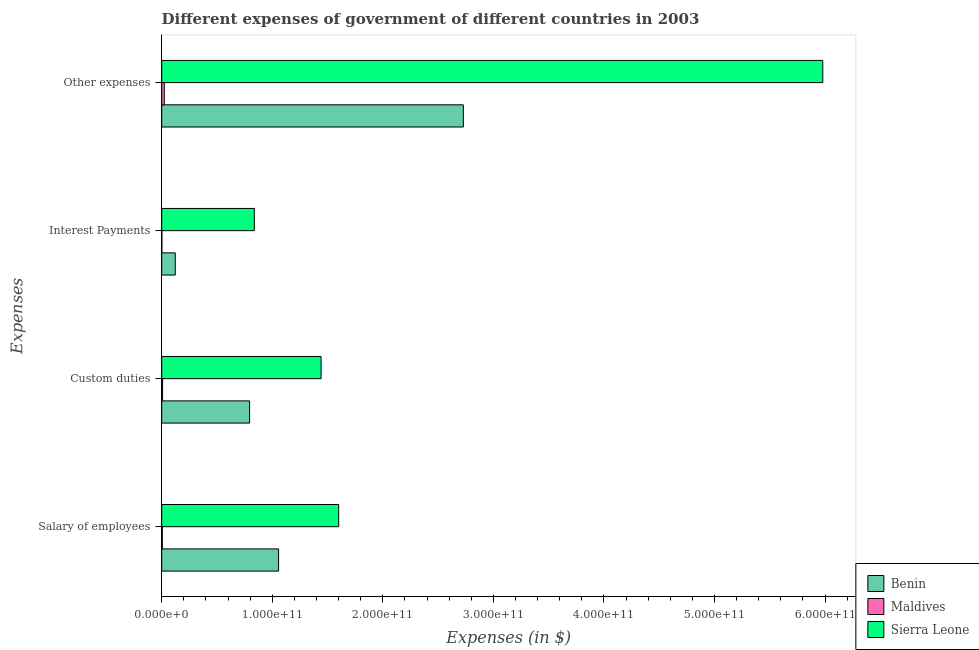How many different coloured bars are there?
Your response must be concise. 3. How many groups of bars are there?
Offer a terse response. 4. Are the number of bars per tick equal to the number of legend labels?
Offer a terse response. Yes. Are the number of bars on each tick of the Y-axis equal?
Your answer should be compact. Yes. How many bars are there on the 4th tick from the top?
Your answer should be compact. 3. What is the label of the 2nd group of bars from the top?
Ensure brevity in your answer.  Interest Payments. What is the amount spent on interest payments in Maldives?
Your answer should be compact. 1.35e+08. Across all countries, what is the maximum amount spent on other expenses?
Keep it short and to the point. 5.98e+11. Across all countries, what is the minimum amount spent on interest payments?
Ensure brevity in your answer.  1.35e+08. In which country was the amount spent on custom duties maximum?
Give a very brief answer. Sierra Leone. In which country was the amount spent on interest payments minimum?
Make the answer very short. Maldives. What is the total amount spent on other expenses in the graph?
Offer a very short reply. 8.73e+11. What is the difference between the amount spent on salary of employees in Maldives and that in Sierra Leone?
Offer a terse response. -1.60e+11. What is the difference between the amount spent on other expenses in Sierra Leone and the amount spent on salary of employees in Maldives?
Give a very brief answer. 5.97e+11. What is the average amount spent on interest payments per country?
Make the answer very short. 3.21e+1. What is the difference between the amount spent on interest payments and amount spent on custom duties in Benin?
Make the answer very short. -6.72e+1. In how many countries, is the amount spent on salary of employees greater than 500000000000 $?
Your answer should be very brief. 0. What is the ratio of the amount spent on salary of employees in Sierra Leone to that in Benin?
Your answer should be very brief. 1.51. Is the amount spent on custom duties in Sierra Leone less than that in Benin?
Make the answer very short. No. Is the difference between the amount spent on custom duties in Sierra Leone and Maldives greater than the difference between the amount spent on interest payments in Sierra Leone and Maldives?
Offer a very short reply. Yes. What is the difference between the highest and the second highest amount spent on interest payments?
Make the answer very short. 7.15e+1. What is the difference between the highest and the lowest amount spent on custom duties?
Offer a terse response. 1.43e+11. In how many countries, is the amount spent on interest payments greater than the average amount spent on interest payments taken over all countries?
Your response must be concise. 1. Is the sum of the amount spent on custom duties in Sierra Leone and Maldives greater than the maximum amount spent on other expenses across all countries?
Your answer should be compact. No. Is it the case that in every country, the sum of the amount spent on custom duties and amount spent on other expenses is greater than the sum of amount spent on interest payments and amount spent on salary of employees?
Your response must be concise. No. What does the 3rd bar from the top in Interest Payments represents?
Provide a short and direct response. Benin. What does the 2nd bar from the bottom in Interest Payments represents?
Offer a very short reply. Maldives. Is it the case that in every country, the sum of the amount spent on salary of employees and amount spent on custom duties is greater than the amount spent on interest payments?
Your answer should be very brief. Yes. How many bars are there?
Make the answer very short. 12. What is the difference between two consecutive major ticks on the X-axis?
Keep it short and to the point. 1.00e+11. Are the values on the major ticks of X-axis written in scientific E-notation?
Make the answer very short. Yes. Does the graph contain any zero values?
Your response must be concise. No. How many legend labels are there?
Your answer should be compact. 3. How are the legend labels stacked?
Offer a terse response. Vertical. What is the title of the graph?
Give a very brief answer. Different expenses of government of different countries in 2003. What is the label or title of the X-axis?
Your answer should be compact. Expenses (in $). What is the label or title of the Y-axis?
Your answer should be very brief. Expenses. What is the Expenses (in $) of Benin in Salary of employees?
Provide a short and direct response. 1.06e+11. What is the Expenses (in $) of Maldives in Salary of employees?
Your response must be concise. 5.64e+08. What is the Expenses (in $) in Sierra Leone in Salary of employees?
Offer a terse response. 1.60e+11. What is the Expenses (in $) of Benin in Custom duties?
Make the answer very short. 7.95e+1. What is the Expenses (in $) of Maldives in Custom duties?
Your answer should be very brief. 8.17e+08. What is the Expenses (in $) in Sierra Leone in Custom duties?
Your answer should be very brief. 1.44e+11. What is the Expenses (in $) of Benin in Interest Payments?
Offer a terse response. 1.23e+1. What is the Expenses (in $) in Maldives in Interest Payments?
Ensure brevity in your answer.  1.35e+08. What is the Expenses (in $) of Sierra Leone in Interest Payments?
Provide a succinct answer. 8.38e+1. What is the Expenses (in $) of Benin in Other expenses?
Offer a very short reply. 2.73e+11. What is the Expenses (in $) in Maldives in Other expenses?
Provide a succinct answer. 2.35e+09. What is the Expenses (in $) of Sierra Leone in Other expenses?
Offer a terse response. 5.98e+11. Across all Expenses, what is the maximum Expenses (in $) in Benin?
Provide a succinct answer. 2.73e+11. Across all Expenses, what is the maximum Expenses (in $) in Maldives?
Your response must be concise. 2.35e+09. Across all Expenses, what is the maximum Expenses (in $) of Sierra Leone?
Your answer should be very brief. 5.98e+11. Across all Expenses, what is the minimum Expenses (in $) of Benin?
Keep it short and to the point. 1.23e+1. Across all Expenses, what is the minimum Expenses (in $) of Maldives?
Your answer should be compact. 1.35e+08. Across all Expenses, what is the minimum Expenses (in $) of Sierra Leone?
Give a very brief answer. 8.38e+1. What is the total Expenses (in $) in Benin in the graph?
Your answer should be very brief. 4.70e+11. What is the total Expenses (in $) in Maldives in the graph?
Keep it short and to the point. 3.86e+09. What is the total Expenses (in $) of Sierra Leone in the graph?
Keep it short and to the point. 9.86e+11. What is the difference between the Expenses (in $) of Benin in Salary of employees and that in Custom duties?
Your answer should be compact. 2.62e+1. What is the difference between the Expenses (in $) of Maldives in Salary of employees and that in Custom duties?
Keep it short and to the point. -2.53e+08. What is the difference between the Expenses (in $) in Sierra Leone in Salary of employees and that in Custom duties?
Your answer should be very brief. 1.59e+1. What is the difference between the Expenses (in $) of Benin in Salary of employees and that in Interest Payments?
Your answer should be compact. 9.35e+1. What is the difference between the Expenses (in $) of Maldives in Salary of employees and that in Interest Payments?
Your answer should be very brief. 4.29e+08. What is the difference between the Expenses (in $) in Sierra Leone in Salary of employees and that in Interest Payments?
Offer a terse response. 7.63e+1. What is the difference between the Expenses (in $) in Benin in Salary of employees and that in Other expenses?
Your answer should be compact. -1.67e+11. What is the difference between the Expenses (in $) in Maldives in Salary of employees and that in Other expenses?
Your answer should be compact. -1.78e+09. What is the difference between the Expenses (in $) in Sierra Leone in Salary of employees and that in Other expenses?
Make the answer very short. -4.38e+11. What is the difference between the Expenses (in $) in Benin in Custom duties and that in Interest Payments?
Give a very brief answer. 6.72e+1. What is the difference between the Expenses (in $) of Maldives in Custom duties and that in Interest Payments?
Offer a very short reply. 6.82e+08. What is the difference between the Expenses (in $) of Sierra Leone in Custom duties and that in Interest Payments?
Provide a succinct answer. 6.04e+1. What is the difference between the Expenses (in $) of Benin in Custom duties and that in Other expenses?
Provide a succinct answer. -1.93e+11. What is the difference between the Expenses (in $) of Maldives in Custom duties and that in Other expenses?
Keep it short and to the point. -1.53e+09. What is the difference between the Expenses (in $) of Sierra Leone in Custom duties and that in Other expenses?
Make the answer very short. -4.54e+11. What is the difference between the Expenses (in $) of Benin in Interest Payments and that in Other expenses?
Your answer should be compact. -2.61e+11. What is the difference between the Expenses (in $) in Maldives in Interest Payments and that in Other expenses?
Offer a very short reply. -2.21e+09. What is the difference between the Expenses (in $) in Sierra Leone in Interest Payments and that in Other expenses?
Provide a succinct answer. -5.14e+11. What is the difference between the Expenses (in $) in Benin in Salary of employees and the Expenses (in $) in Maldives in Custom duties?
Give a very brief answer. 1.05e+11. What is the difference between the Expenses (in $) of Benin in Salary of employees and the Expenses (in $) of Sierra Leone in Custom duties?
Make the answer very short. -3.84e+1. What is the difference between the Expenses (in $) in Maldives in Salary of employees and the Expenses (in $) in Sierra Leone in Custom duties?
Provide a short and direct response. -1.44e+11. What is the difference between the Expenses (in $) in Benin in Salary of employees and the Expenses (in $) in Maldives in Interest Payments?
Your response must be concise. 1.06e+11. What is the difference between the Expenses (in $) in Benin in Salary of employees and the Expenses (in $) in Sierra Leone in Interest Payments?
Your response must be concise. 2.19e+1. What is the difference between the Expenses (in $) of Maldives in Salary of employees and the Expenses (in $) of Sierra Leone in Interest Payments?
Give a very brief answer. -8.32e+1. What is the difference between the Expenses (in $) in Benin in Salary of employees and the Expenses (in $) in Maldives in Other expenses?
Give a very brief answer. 1.03e+11. What is the difference between the Expenses (in $) in Benin in Salary of employees and the Expenses (in $) in Sierra Leone in Other expenses?
Your response must be concise. -4.92e+11. What is the difference between the Expenses (in $) in Maldives in Salary of employees and the Expenses (in $) in Sierra Leone in Other expenses?
Provide a succinct answer. -5.97e+11. What is the difference between the Expenses (in $) of Benin in Custom duties and the Expenses (in $) of Maldives in Interest Payments?
Offer a very short reply. 7.94e+1. What is the difference between the Expenses (in $) of Benin in Custom duties and the Expenses (in $) of Sierra Leone in Interest Payments?
Provide a succinct answer. -4.28e+09. What is the difference between the Expenses (in $) in Maldives in Custom duties and the Expenses (in $) in Sierra Leone in Interest Payments?
Provide a succinct answer. -8.30e+1. What is the difference between the Expenses (in $) in Benin in Custom duties and the Expenses (in $) in Maldives in Other expenses?
Your response must be concise. 7.71e+1. What is the difference between the Expenses (in $) of Benin in Custom duties and the Expenses (in $) of Sierra Leone in Other expenses?
Offer a very short reply. -5.19e+11. What is the difference between the Expenses (in $) in Maldives in Custom duties and the Expenses (in $) in Sierra Leone in Other expenses?
Your answer should be compact. -5.97e+11. What is the difference between the Expenses (in $) in Benin in Interest Payments and the Expenses (in $) in Maldives in Other expenses?
Provide a succinct answer. 9.92e+09. What is the difference between the Expenses (in $) in Benin in Interest Payments and the Expenses (in $) in Sierra Leone in Other expenses?
Provide a succinct answer. -5.86e+11. What is the difference between the Expenses (in $) in Maldives in Interest Payments and the Expenses (in $) in Sierra Leone in Other expenses?
Your answer should be compact. -5.98e+11. What is the average Expenses (in $) of Benin per Expenses?
Keep it short and to the point. 1.18e+11. What is the average Expenses (in $) in Maldives per Expenses?
Provide a succinct answer. 9.66e+08. What is the average Expenses (in $) in Sierra Leone per Expenses?
Keep it short and to the point. 2.47e+11. What is the difference between the Expenses (in $) in Benin and Expenses (in $) in Maldives in Salary of employees?
Offer a terse response. 1.05e+11. What is the difference between the Expenses (in $) in Benin and Expenses (in $) in Sierra Leone in Salary of employees?
Make the answer very short. -5.44e+1. What is the difference between the Expenses (in $) of Maldives and Expenses (in $) of Sierra Leone in Salary of employees?
Provide a short and direct response. -1.60e+11. What is the difference between the Expenses (in $) in Benin and Expenses (in $) in Maldives in Custom duties?
Your response must be concise. 7.87e+1. What is the difference between the Expenses (in $) in Benin and Expenses (in $) in Sierra Leone in Custom duties?
Your answer should be very brief. -6.47e+1. What is the difference between the Expenses (in $) of Maldives and Expenses (in $) of Sierra Leone in Custom duties?
Your response must be concise. -1.43e+11. What is the difference between the Expenses (in $) in Benin and Expenses (in $) in Maldives in Interest Payments?
Make the answer very short. 1.21e+1. What is the difference between the Expenses (in $) in Benin and Expenses (in $) in Sierra Leone in Interest Payments?
Provide a short and direct response. -7.15e+1. What is the difference between the Expenses (in $) in Maldives and Expenses (in $) in Sierra Leone in Interest Payments?
Offer a very short reply. -8.36e+1. What is the difference between the Expenses (in $) in Benin and Expenses (in $) in Maldives in Other expenses?
Your answer should be compact. 2.71e+11. What is the difference between the Expenses (in $) in Benin and Expenses (in $) in Sierra Leone in Other expenses?
Make the answer very short. -3.25e+11. What is the difference between the Expenses (in $) in Maldives and Expenses (in $) in Sierra Leone in Other expenses?
Your answer should be compact. -5.96e+11. What is the ratio of the Expenses (in $) of Benin in Salary of employees to that in Custom duties?
Ensure brevity in your answer.  1.33. What is the ratio of the Expenses (in $) of Maldives in Salary of employees to that in Custom duties?
Offer a very short reply. 0.69. What is the ratio of the Expenses (in $) in Sierra Leone in Salary of employees to that in Custom duties?
Offer a very short reply. 1.11. What is the ratio of the Expenses (in $) in Benin in Salary of employees to that in Interest Payments?
Keep it short and to the point. 8.62. What is the ratio of the Expenses (in $) of Maldives in Salary of employees to that in Interest Payments?
Ensure brevity in your answer.  4.17. What is the ratio of the Expenses (in $) of Sierra Leone in Salary of employees to that in Interest Payments?
Provide a short and direct response. 1.91. What is the ratio of the Expenses (in $) in Benin in Salary of employees to that in Other expenses?
Ensure brevity in your answer.  0.39. What is the ratio of the Expenses (in $) of Maldives in Salary of employees to that in Other expenses?
Keep it short and to the point. 0.24. What is the ratio of the Expenses (in $) in Sierra Leone in Salary of employees to that in Other expenses?
Give a very brief answer. 0.27. What is the ratio of the Expenses (in $) in Benin in Custom duties to that in Interest Payments?
Your response must be concise. 6.48. What is the ratio of the Expenses (in $) of Maldives in Custom duties to that in Interest Payments?
Your response must be concise. 6.04. What is the ratio of the Expenses (in $) of Sierra Leone in Custom duties to that in Interest Payments?
Keep it short and to the point. 1.72. What is the ratio of the Expenses (in $) in Benin in Custom duties to that in Other expenses?
Ensure brevity in your answer.  0.29. What is the ratio of the Expenses (in $) of Maldives in Custom duties to that in Other expenses?
Your answer should be very brief. 0.35. What is the ratio of the Expenses (in $) of Sierra Leone in Custom duties to that in Other expenses?
Keep it short and to the point. 0.24. What is the ratio of the Expenses (in $) of Benin in Interest Payments to that in Other expenses?
Provide a short and direct response. 0.04. What is the ratio of the Expenses (in $) in Maldives in Interest Payments to that in Other expenses?
Your answer should be compact. 0.06. What is the ratio of the Expenses (in $) of Sierra Leone in Interest Payments to that in Other expenses?
Your answer should be very brief. 0.14. What is the difference between the highest and the second highest Expenses (in $) of Benin?
Your answer should be very brief. 1.67e+11. What is the difference between the highest and the second highest Expenses (in $) of Maldives?
Ensure brevity in your answer.  1.53e+09. What is the difference between the highest and the second highest Expenses (in $) of Sierra Leone?
Provide a short and direct response. 4.38e+11. What is the difference between the highest and the lowest Expenses (in $) of Benin?
Your answer should be very brief. 2.61e+11. What is the difference between the highest and the lowest Expenses (in $) of Maldives?
Give a very brief answer. 2.21e+09. What is the difference between the highest and the lowest Expenses (in $) of Sierra Leone?
Ensure brevity in your answer.  5.14e+11. 